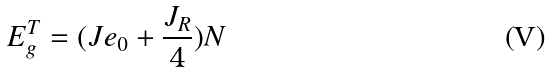<formula> <loc_0><loc_0><loc_500><loc_500>E ^ { T } _ { g } = ( J e _ { 0 } + \frac { J _ { R } } { 4 } ) N</formula> 